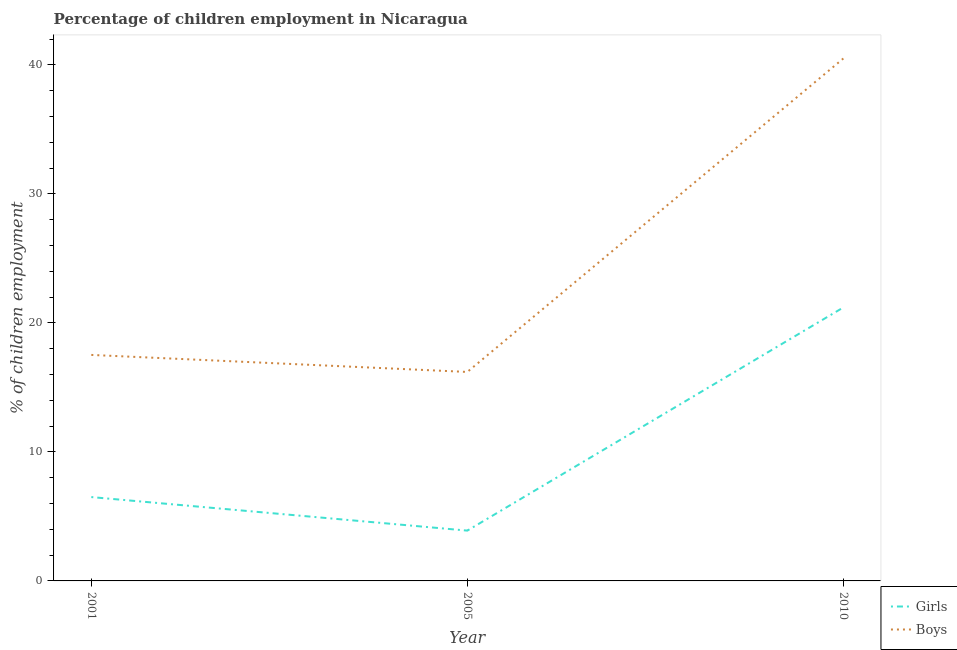Does the line corresponding to percentage of employed boys intersect with the line corresponding to percentage of employed girls?
Keep it short and to the point. No. Is the number of lines equal to the number of legend labels?
Your answer should be very brief. Yes. What is the percentage of employed boys in 2001?
Offer a terse response. 17.52. Across all years, what is the maximum percentage of employed boys?
Offer a very short reply. 40.5. In which year was the percentage of employed boys maximum?
Ensure brevity in your answer.  2010. In which year was the percentage of employed girls minimum?
Keep it short and to the point. 2005. What is the total percentage of employed boys in the graph?
Make the answer very short. 74.22. What is the difference between the percentage of employed girls in 2001 and that in 2010?
Keep it short and to the point. -14.7. What is the difference between the percentage of employed girls in 2005 and the percentage of employed boys in 2001?
Your answer should be compact. -13.62. What is the average percentage of employed boys per year?
Provide a short and direct response. 24.74. In the year 2001, what is the difference between the percentage of employed girls and percentage of employed boys?
Offer a terse response. -11.02. In how many years, is the percentage of employed boys greater than 14 %?
Your answer should be compact. 3. What is the ratio of the percentage of employed boys in 2001 to that in 2010?
Give a very brief answer. 0.43. Is the percentage of employed girls in 2001 less than that in 2005?
Your answer should be compact. No. Is the difference between the percentage of employed girls in 2001 and 2010 greater than the difference between the percentage of employed boys in 2001 and 2010?
Ensure brevity in your answer.  Yes. What is the difference between the highest and the second highest percentage of employed boys?
Make the answer very short. 22.98. What is the difference between the highest and the lowest percentage of employed boys?
Keep it short and to the point. 24.3. Does the percentage of employed girls monotonically increase over the years?
Keep it short and to the point. No. Is the percentage of employed girls strictly greater than the percentage of employed boys over the years?
Give a very brief answer. No. How many lines are there?
Provide a succinct answer. 2. Where does the legend appear in the graph?
Offer a very short reply. Bottom right. What is the title of the graph?
Give a very brief answer. Percentage of children employment in Nicaragua. Does "Drinking water services" appear as one of the legend labels in the graph?
Your response must be concise. No. What is the label or title of the Y-axis?
Offer a very short reply. % of children employment. What is the % of children employment of Girls in 2001?
Make the answer very short. 6.5. What is the % of children employment of Boys in 2001?
Provide a succinct answer. 17.52. What is the % of children employment in Girls in 2010?
Offer a very short reply. 21.2. What is the % of children employment of Boys in 2010?
Offer a very short reply. 40.5. Across all years, what is the maximum % of children employment in Girls?
Provide a succinct answer. 21.2. Across all years, what is the maximum % of children employment in Boys?
Offer a terse response. 40.5. Across all years, what is the minimum % of children employment in Girls?
Offer a very short reply. 3.9. Across all years, what is the minimum % of children employment of Boys?
Offer a terse response. 16.2. What is the total % of children employment in Girls in the graph?
Your answer should be very brief. 31.6. What is the total % of children employment in Boys in the graph?
Your answer should be compact. 74.22. What is the difference between the % of children employment in Girls in 2001 and that in 2005?
Provide a short and direct response. 2.6. What is the difference between the % of children employment of Boys in 2001 and that in 2005?
Provide a short and direct response. 1.32. What is the difference between the % of children employment of Girls in 2001 and that in 2010?
Offer a very short reply. -14.7. What is the difference between the % of children employment in Boys in 2001 and that in 2010?
Offer a terse response. -22.98. What is the difference between the % of children employment in Girls in 2005 and that in 2010?
Ensure brevity in your answer.  -17.3. What is the difference between the % of children employment in Boys in 2005 and that in 2010?
Offer a very short reply. -24.3. What is the difference between the % of children employment of Girls in 2001 and the % of children employment of Boys in 2005?
Keep it short and to the point. -9.7. What is the difference between the % of children employment in Girls in 2001 and the % of children employment in Boys in 2010?
Your response must be concise. -34. What is the difference between the % of children employment in Girls in 2005 and the % of children employment in Boys in 2010?
Ensure brevity in your answer.  -36.6. What is the average % of children employment of Girls per year?
Provide a succinct answer. 10.53. What is the average % of children employment in Boys per year?
Give a very brief answer. 24.74. In the year 2001, what is the difference between the % of children employment of Girls and % of children employment of Boys?
Offer a very short reply. -11.02. In the year 2005, what is the difference between the % of children employment of Girls and % of children employment of Boys?
Make the answer very short. -12.3. In the year 2010, what is the difference between the % of children employment of Girls and % of children employment of Boys?
Offer a very short reply. -19.3. What is the ratio of the % of children employment of Girls in 2001 to that in 2005?
Give a very brief answer. 1.67. What is the ratio of the % of children employment of Boys in 2001 to that in 2005?
Ensure brevity in your answer.  1.08. What is the ratio of the % of children employment in Girls in 2001 to that in 2010?
Offer a terse response. 0.31. What is the ratio of the % of children employment in Boys in 2001 to that in 2010?
Your answer should be very brief. 0.43. What is the ratio of the % of children employment in Girls in 2005 to that in 2010?
Make the answer very short. 0.18. What is the difference between the highest and the second highest % of children employment in Girls?
Offer a very short reply. 14.7. What is the difference between the highest and the second highest % of children employment of Boys?
Offer a terse response. 22.98. What is the difference between the highest and the lowest % of children employment in Boys?
Provide a short and direct response. 24.3. 